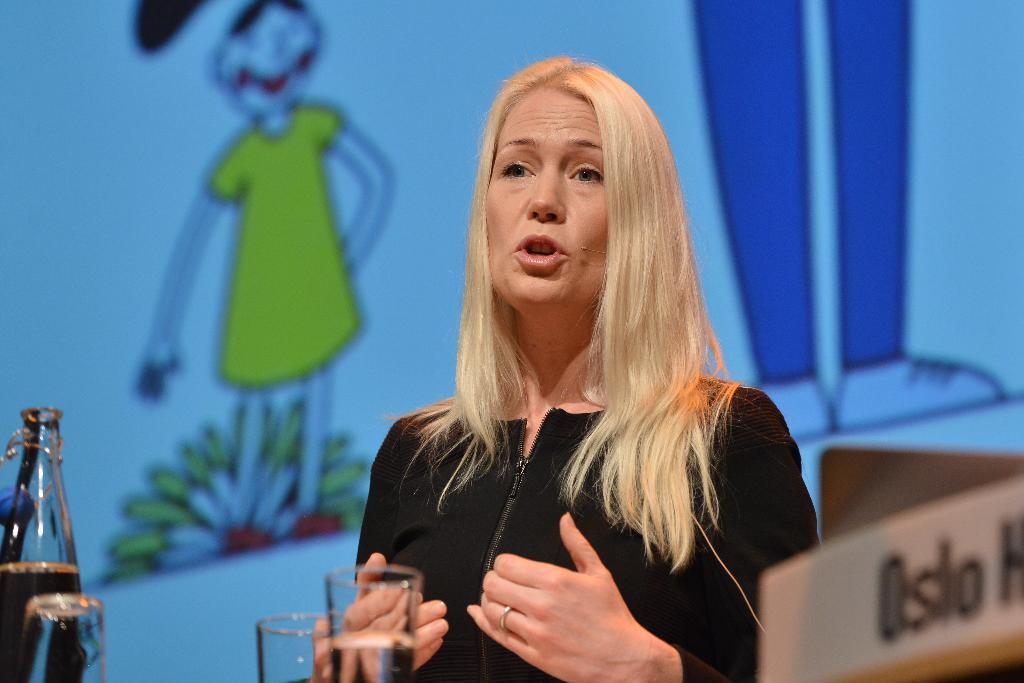Who is present in the image? There is a woman in the image. What is the woman doing? The woman is talking. What objects can be seen on the table? There is a glass, a bottle, and a nameplate on the table. What can be seen in the background of the image? There is a sketch in the background of the image. How many snakes are slithering across the table in the image? There are no snakes present in the image; the table only contains a glass, a bottle, and a nameplate. What type of vein is visible on the woman's arm in the image? There is no visible vein on the woman's arm in the image, nor is there any indication that her arm is visible. 